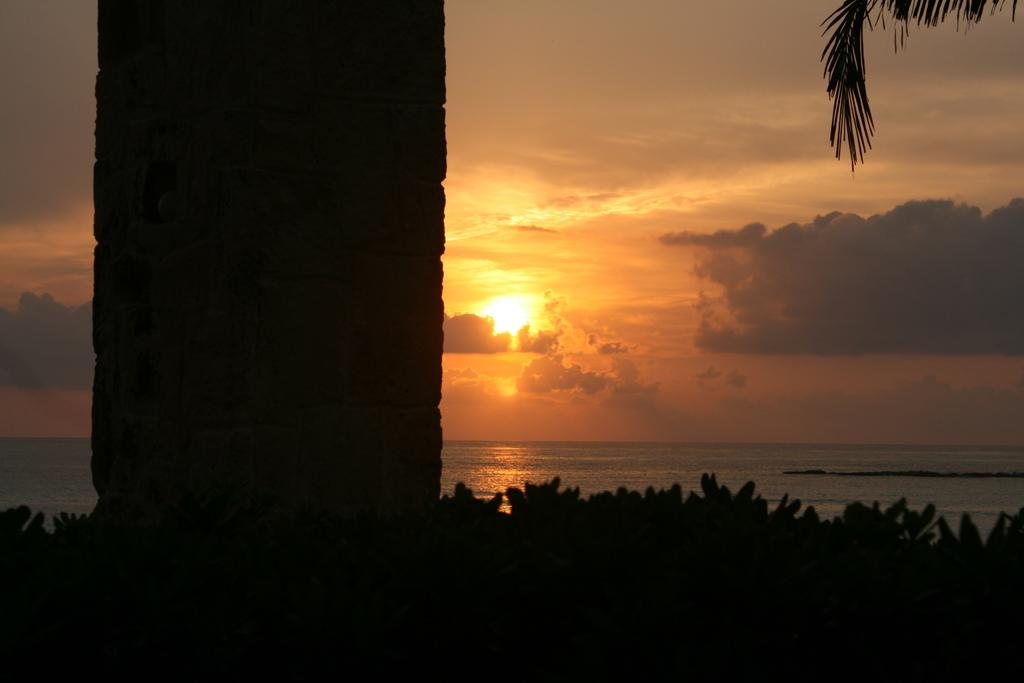What is the main structure in the image? There is a pillar made with stone in the image. What is located near the pillar? There are plants near the pillar. What else can be seen in the image besides the pillar and plants? Water and the sky are visible in the image. What type of behavior does the bear exhibit in the image? There is no bear present in the image, so it is not possible to determine its behavior. 